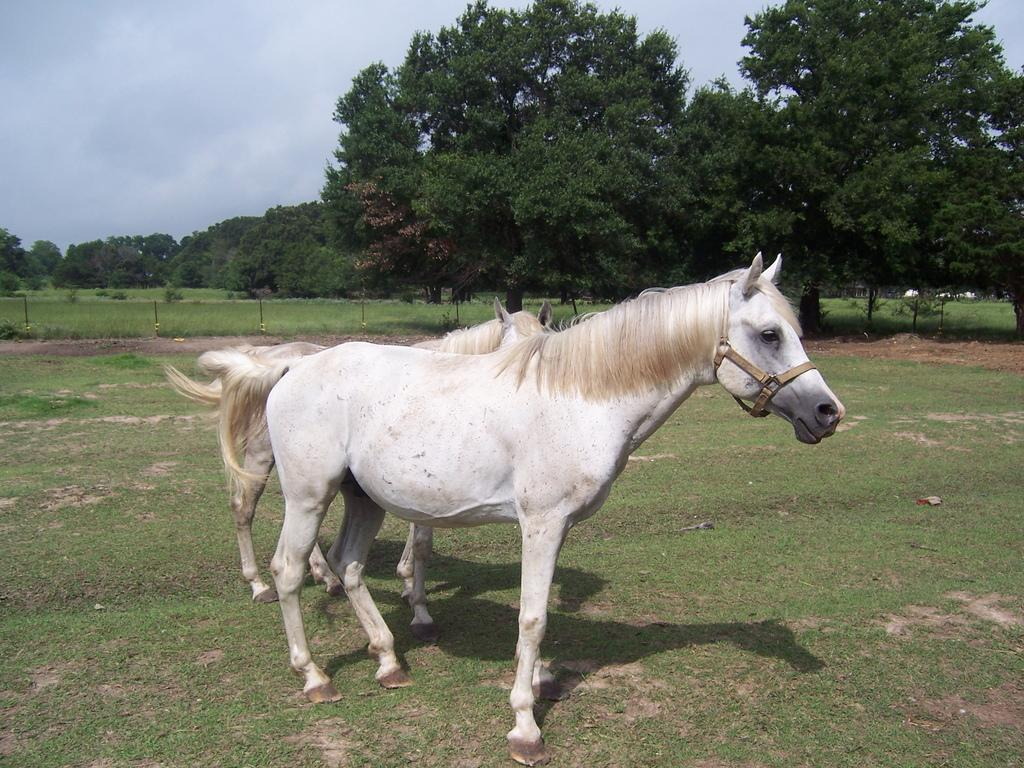What animals are in the center of the image? There are horses in the center of the image. What is the surface on which the horses are standing? The horses are on the grass. What can be seen in the background of the image? There are trees, grass, and the sky visible in the background of the image. What is the condition of the sky in the image? Clouds are present in the sky. What color is the crayon used to draw the horses in the image? There is no crayon present in the image; it is a photograph of real horses. What holiday is being celebrated in the image? There is no indication of a holiday being celebrated in the image. 